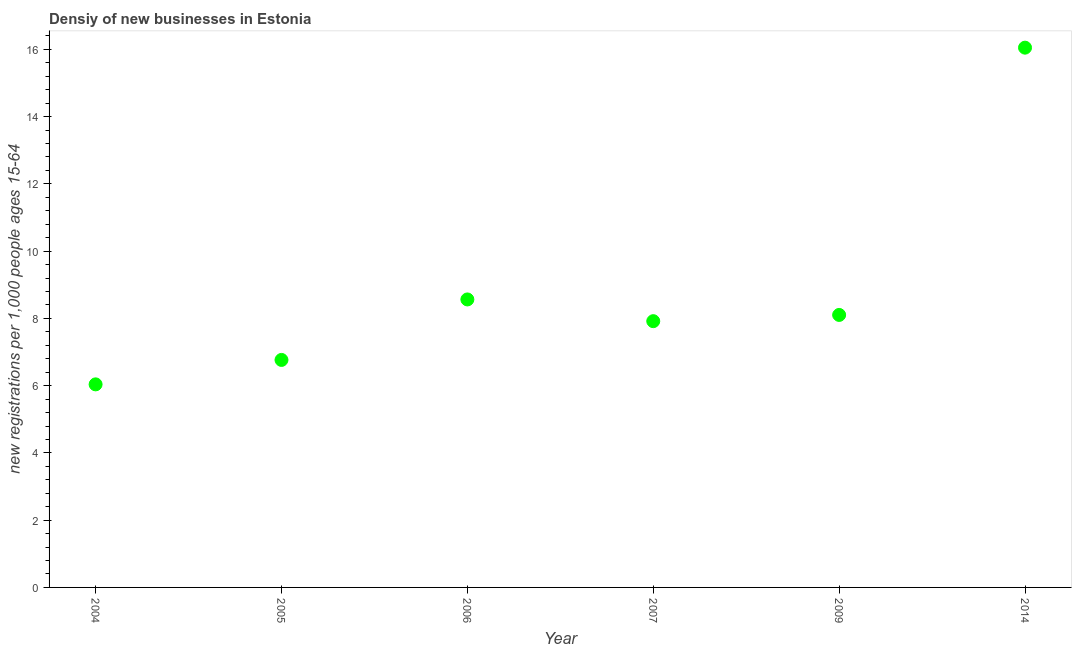What is the density of new business in 2009?
Provide a short and direct response. 8.1. Across all years, what is the maximum density of new business?
Offer a very short reply. 16.05. Across all years, what is the minimum density of new business?
Give a very brief answer. 6.04. In which year was the density of new business maximum?
Ensure brevity in your answer.  2014. In which year was the density of new business minimum?
Give a very brief answer. 2004. What is the sum of the density of new business?
Your answer should be very brief. 53.44. What is the difference between the density of new business in 2005 and 2007?
Your answer should be very brief. -1.15. What is the average density of new business per year?
Make the answer very short. 8.91. What is the median density of new business?
Keep it short and to the point. 8.01. In how many years, is the density of new business greater than 2.8 ?
Give a very brief answer. 6. Do a majority of the years between 2006 and 2005 (inclusive) have density of new business greater than 12.8 ?
Keep it short and to the point. No. What is the ratio of the density of new business in 2005 to that in 2007?
Give a very brief answer. 0.85. What is the difference between the highest and the second highest density of new business?
Keep it short and to the point. 7.49. What is the difference between the highest and the lowest density of new business?
Provide a succinct answer. 10.01. In how many years, is the density of new business greater than the average density of new business taken over all years?
Give a very brief answer. 1. Does the density of new business monotonically increase over the years?
Ensure brevity in your answer.  No. What is the difference between two consecutive major ticks on the Y-axis?
Provide a succinct answer. 2. Does the graph contain grids?
Keep it short and to the point. No. What is the title of the graph?
Provide a succinct answer. Densiy of new businesses in Estonia. What is the label or title of the X-axis?
Offer a terse response. Year. What is the label or title of the Y-axis?
Provide a succinct answer. New registrations per 1,0 people ages 15-64. What is the new registrations per 1,000 people ages 15-64 in 2004?
Give a very brief answer. 6.04. What is the new registrations per 1,000 people ages 15-64 in 2005?
Your response must be concise. 6.76. What is the new registrations per 1,000 people ages 15-64 in 2006?
Give a very brief answer. 8.56. What is the new registrations per 1,000 people ages 15-64 in 2007?
Your answer should be very brief. 7.92. What is the new registrations per 1,000 people ages 15-64 in 2009?
Give a very brief answer. 8.1. What is the new registrations per 1,000 people ages 15-64 in 2014?
Offer a very short reply. 16.05. What is the difference between the new registrations per 1,000 people ages 15-64 in 2004 and 2005?
Provide a succinct answer. -0.73. What is the difference between the new registrations per 1,000 people ages 15-64 in 2004 and 2006?
Provide a short and direct response. -2.53. What is the difference between the new registrations per 1,000 people ages 15-64 in 2004 and 2007?
Your answer should be very brief. -1.88. What is the difference between the new registrations per 1,000 people ages 15-64 in 2004 and 2009?
Provide a short and direct response. -2.06. What is the difference between the new registrations per 1,000 people ages 15-64 in 2004 and 2014?
Offer a terse response. -10.01. What is the difference between the new registrations per 1,000 people ages 15-64 in 2005 and 2006?
Your answer should be compact. -1.8. What is the difference between the new registrations per 1,000 people ages 15-64 in 2005 and 2007?
Keep it short and to the point. -1.15. What is the difference between the new registrations per 1,000 people ages 15-64 in 2005 and 2009?
Offer a terse response. -1.34. What is the difference between the new registrations per 1,000 people ages 15-64 in 2005 and 2014?
Offer a very short reply. -9.29. What is the difference between the new registrations per 1,000 people ages 15-64 in 2006 and 2007?
Offer a terse response. 0.65. What is the difference between the new registrations per 1,000 people ages 15-64 in 2006 and 2009?
Your response must be concise. 0.46. What is the difference between the new registrations per 1,000 people ages 15-64 in 2006 and 2014?
Offer a very short reply. -7.49. What is the difference between the new registrations per 1,000 people ages 15-64 in 2007 and 2009?
Ensure brevity in your answer.  -0.19. What is the difference between the new registrations per 1,000 people ages 15-64 in 2007 and 2014?
Your answer should be very brief. -8.13. What is the difference between the new registrations per 1,000 people ages 15-64 in 2009 and 2014?
Your response must be concise. -7.95. What is the ratio of the new registrations per 1,000 people ages 15-64 in 2004 to that in 2005?
Provide a succinct answer. 0.89. What is the ratio of the new registrations per 1,000 people ages 15-64 in 2004 to that in 2006?
Your response must be concise. 0.7. What is the ratio of the new registrations per 1,000 people ages 15-64 in 2004 to that in 2007?
Offer a terse response. 0.76. What is the ratio of the new registrations per 1,000 people ages 15-64 in 2004 to that in 2009?
Give a very brief answer. 0.74. What is the ratio of the new registrations per 1,000 people ages 15-64 in 2004 to that in 2014?
Offer a terse response. 0.38. What is the ratio of the new registrations per 1,000 people ages 15-64 in 2005 to that in 2006?
Ensure brevity in your answer.  0.79. What is the ratio of the new registrations per 1,000 people ages 15-64 in 2005 to that in 2007?
Your answer should be compact. 0.85. What is the ratio of the new registrations per 1,000 people ages 15-64 in 2005 to that in 2009?
Offer a terse response. 0.83. What is the ratio of the new registrations per 1,000 people ages 15-64 in 2005 to that in 2014?
Ensure brevity in your answer.  0.42. What is the ratio of the new registrations per 1,000 people ages 15-64 in 2006 to that in 2007?
Offer a terse response. 1.08. What is the ratio of the new registrations per 1,000 people ages 15-64 in 2006 to that in 2009?
Your response must be concise. 1.06. What is the ratio of the new registrations per 1,000 people ages 15-64 in 2006 to that in 2014?
Offer a very short reply. 0.53. What is the ratio of the new registrations per 1,000 people ages 15-64 in 2007 to that in 2009?
Give a very brief answer. 0.98. What is the ratio of the new registrations per 1,000 people ages 15-64 in 2007 to that in 2014?
Provide a succinct answer. 0.49. What is the ratio of the new registrations per 1,000 people ages 15-64 in 2009 to that in 2014?
Provide a succinct answer. 0.51. 